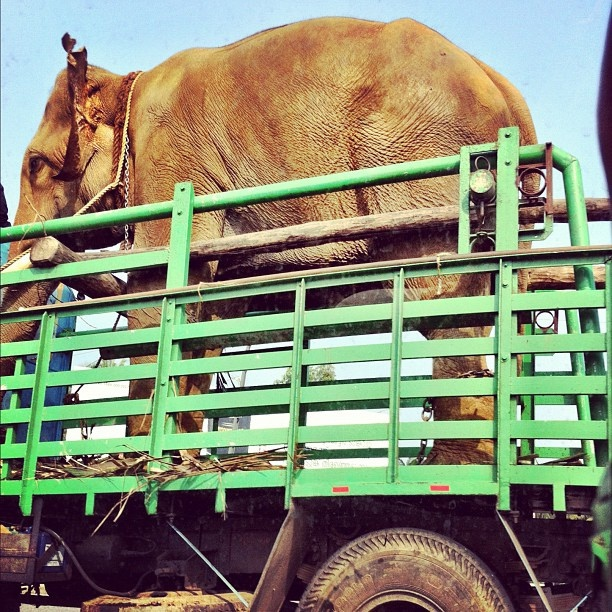Describe the objects in this image and their specific colors. I can see truck in gray, black, lightgreen, ivory, and maroon tones and elephant in gray, tan, lightgreen, black, and salmon tones in this image. 